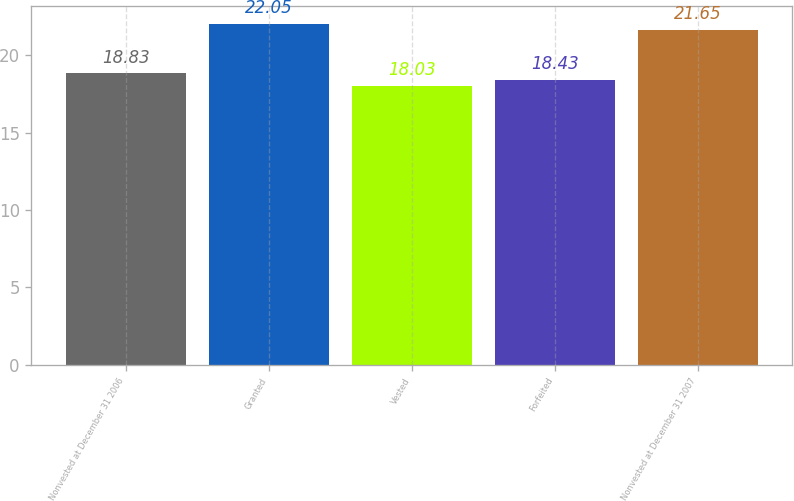Convert chart to OTSL. <chart><loc_0><loc_0><loc_500><loc_500><bar_chart><fcel>Nonvested at December 31 2006<fcel>Granted<fcel>Vested<fcel>Forfeited<fcel>Nonvested at December 31 2007<nl><fcel>18.83<fcel>22.05<fcel>18.03<fcel>18.43<fcel>21.65<nl></chart> 